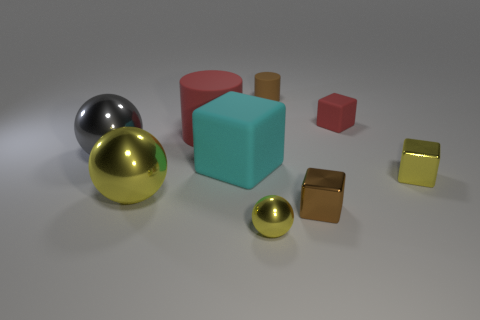Subtract all gray blocks. Subtract all red cylinders. How many blocks are left? 4 Add 1 small metal spheres. How many objects exist? 10 Subtract all cubes. How many objects are left? 5 Add 1 red rubber cylinders. How many red rubber cylinders are left? 2 Add 8 big gray metallic cylinders. How many big gray metallic cylinders exist? 8 Subtract 1 yellow cubes. How many objects are left? 8 Subtract all small cyan matte cubes. Subtract all large yellow metal spheres. How many objects are left? 8 